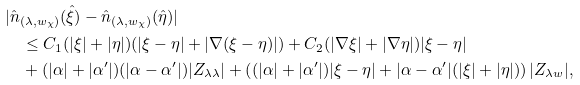<formula> <loc_0><loc_0><loc_500><loc_500>& | \hat { n } _ { ( \lambda , w _ { \chi } ) } ( \hat { \xi } ) - \hat { n } _ { ( \lambda , w _ { \chi } ) } ( \hat { \eta } ) | \\ & \quad \leq C _ { 1 } ( | \xi | + | \eta | ) ( | \xi - \eta | + | \nabla ( \xi - \eta ) | ) + C _ { 2 } ( | \nabla \xi | + | \nabla \eta | ) | \xi - \eta | \\ & \quad + ( | \alpha | + | \alpha ^ { \prime } | ) ( | \alpha - \alpha ^ { \prime } | ) | Z _ { \lambda \lambda } | + \left ( ( | \alpha | + | \alpha ^ { \prime } | ) | \xi - \eta | + | \alpha - \alpha ^ { \prime } | ( | \xi | + | \eta | ) \right ) | Z _ { \lambda w } | ,</formula> 